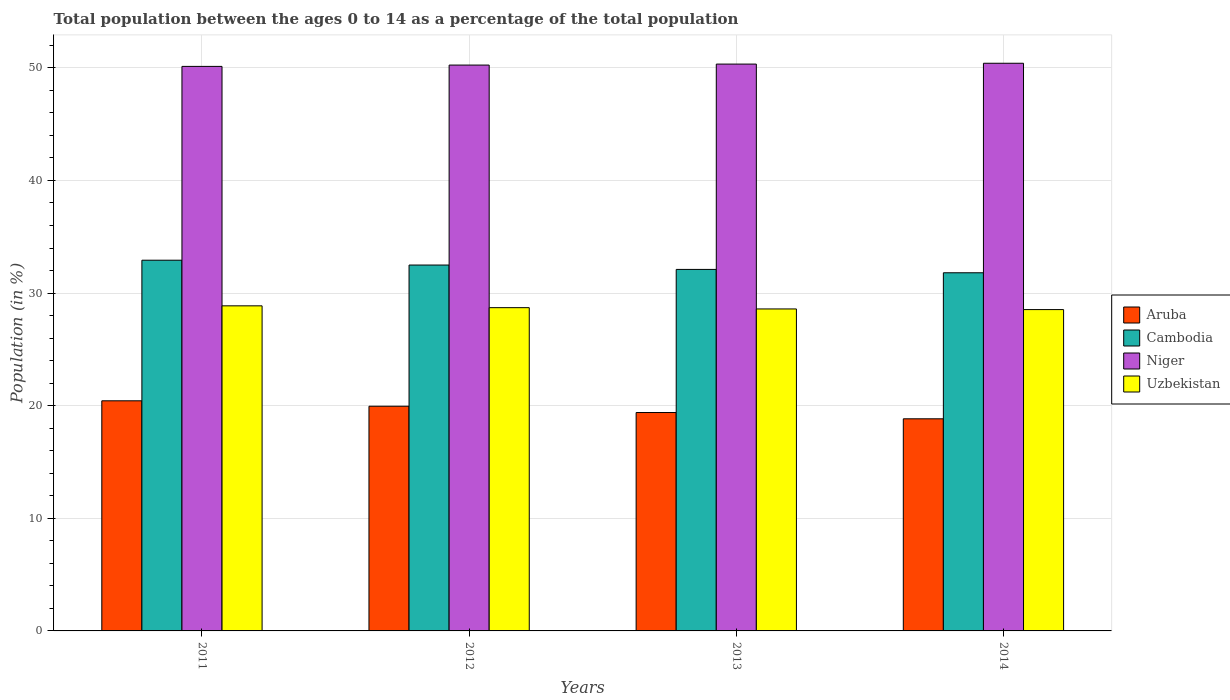How many different coloured bars are there?
Your response must be concise. 4. Are the number of bars per tick equal to the number of legend labels?
Give a very brief answer. Yes. Are the number of bars on each tick of the X-axis equal?
Offer a very short reply. Yes. How many bars are there on the 3rd tick from the left?
Ensure brevity in your answer.  4. How many bars are there on the 2nd tick from the right?
Your answer should be very brief. 4. What is the label of the 3rd group of bars from the left?
Your response must be concise. 2013. What is the percentage of the population ages 0 to 14 in Aruba in 2011?
Provide a short and direct response. 20.43. Across all years, what is the maximum percentage of the population ages 0 to 14 in Cambodia?
Your response must be concise. 32.92. Across all years, what is the minimum percentage of the population ages 0 to 14 in Cambodia?
Provide a short and direct response. 31.8. In which year was the percentage of the population ages 0 to 14 in Cambodia maximum?
Make the answer very short. 2011. What is the total percentage of the population ages 0 to 14 in Aruba in the graph?
Provide a short and direct response. 78.62. What is the difference between the percentage of the population ages 0 to 14 in Niger in 2013 and that in 2014?
Your answer should be compact. -0.07. What is the difference between the percentage of the population ages 0 to 14 in Aruba in 2012 and the percentage of the population ages 0 to 14 in Uzbekistan in 2013?
Offer a very short reply. -8.64. What is the average percentage of the population ages 0 to 14 in Cambodia per year?
Your response must be concise. 32.33. In the year 2013, what is the difference between the percentage of the population ages 0 to 14 in Niger and percentage of the population ages 0 to 14 in Uzbekistan?
Give a very brief answer. 21.74. In how many years, is the percentage of the population ages 0 to 14 in Cambodia greater than 26?
Keep it short and to the point. 4. What is the ratio of the percentage of the population ages 0 to 14 in Niger in 2011 to that in 2013?
Your answer should be very brief. 1. Is the percentage of the population ages 0 to 14 in Aruba in 2011 less than that in 2014?
Ensure brevity in your answer.  No. Is the difference between the percentage of the population ages 0 to 14 in Niger in 2012 and 2013 greater than the difference between the percentage of the population ages 0 to 14 in Uzbekistan in 2012 and 2013?
Provide a short and direct response. No. What is the difference between the highest and the second highest percentage of the population ages 0 to 14 in Aruba?
Offer a very short reply. 0.48. What is the difference between the highest and the lowest percentage of the population ages 0 to 14 in Niger?
Give a very brief answer. 0.28. In how many years, is the percentage of the population ages 0 to 14 in Niger greater than the average percentage of the population ages 0 to 14 in Niger taken over all years?
Offer a very short reply. 2. What does the 2nd bar from the left in 2014 represents?
Keep it short and to the point. Cambodia. What does the 1st bar from the right in 2012 represents?
Make the answer very short. Uzbekistan. How many bars are there?
Offer a terse response. 16. Are all the bars in the graph horizontal?
Your answer should be very brief. No. How many years are there in the graph?
Offer a terse response. 4. Where does the legend appear in the graph?
Keep it short and to the point. Center right. What is the title of the graph?
Offer a terse response. Total population between the ages 0 to 14 as a percentage of the total population. What is the label or title of the X-axis?
Offer a very short reply. Years. What is the Population (in %) in Aruba in 2011?
Provide a short and direct response. 20.43. What is the Population (in %) of Cambodia in 2011?
Your response must be concise. 32.92. What is the Population (in %) of Niger in 2011?
Your response must be concise. 50.13. What is the Population (in %) of Uzbekistan in 2011?
Provide a succinct answer. 28.87. What is the Population (in %) of Aruba in 2012?
Offer a terse response. 19.95. What is the Population (in %) in Cambodia in 2012?
Offer a very short reply. 32.49. What is the Population (in %) in Niger in 2012?
Make the answer very short. 50.25. What is the Population (in %) in Uzbekistan in 2012?
Your answer should be very brief. 28.71. What is the Population (in %) in Aruba in 2013?
Offer a very short reply. 19.39. What is the Population (in %) in Cambodia in 2013?
Your response must be concise. 32.1. What is the Population (in %) in Niger in 2013?
Offer a terse response. 50.34. What is the Population (in %) in Uzbekistan in 2013?
Offer a very short reply. 28.59. What is the Population (in %) in Aruba in 2014?
Offer a terse response. 18.84. What is the Population (in %) in Cambodia in 2014?
Give a very brief answer. 31.8. What is the Population (in %) of Niger in 2014?
Your answer should be compact. 50.41. What is the Population (in %) in Uzbekistan in 2014?
Provide a succinct answer. 28.53. Across all years, what is the maximum Population (in %) in Aruba?
Your answer should be compact. 20.43. Across all years, what is the maximum Population (in %) in Cambodia?
Provide a short and direct response. 32.92. Across all years, what is the maximum Population (in %) in Niger?
Offer a terse response. 50.41. Across all years, what is the maximum Population (in %) of Uzbekistan?
Keep it short and to the point. 28.87. Across all years, what is the minimum Population (in %) of Aruba?
Make the answer very short. 18.84. Across all years, what is the minimum Population (in %) in Cambodia?
Provide a short and direct response. 31.8. Across all years, what is the minimum Population (in %) in Niger?
Provide a succinct answer. 50.13. Across all years, what is the minimum Population (in %) in Uzbekistan?
Make the answer very short. 28.53. What is the total Population (in %) of Aruba in the graph?
Offer a very short reply. 78.62. What is the total Population (in %) in Cambodia in the graph?
Provide a succinct answer. 129.32. What is the total Population (in %) of Niger in the graph?
Give a very brief answer. 201.12. What is the total Population (in %) in Uzbekistan in the graph?
Offer a terse response. 114.7. What is the difference between the Population (in %) of Aruba in 2011 and that in 2012?
Your answer should be very brief. 0.48. What is the difference between the Population (in %) in Cambodia in 2011 and that in 2012?
Ensure brevity in your answer.  0.43. What is the difference between the Population (in %) in Niger in 2011 and that in 2012?
Your answer should be very brief. -0.12. What is the difference between the Population (in %) of Uzbekistan in 2011 and that in 2012?
Offer a terse response. 0.16. What is the difference between the Population (in %) of Aruba in 2011 and that in 2013?
Provide a succinct answer. 1.04. What is the difference between the Population (in %) of Cambodia in 2011 and that in 2013?
Provide a short and direct response. 0.82. What is the difference between the Population (in %) in Niger in 2011 and that in 2013?
Ensure brevity in your answer.  -0.21. What is the difference between the Population (in %) in Uzbekistan in 2011 and that in 2013?
Make the answer very short. 0.28. What is the difference between the Population (in %) in Aruba in 2011 and that in 2014?
Keep it short and to the point. 1.6. What is the difference between the Population (in %) of Cambodia in 2011 and that in 2014?
Make the answer very short. 1.12. What is the difference between the Population (in %) in Niger in 2011 and that in 2014?
Provide a succinct answer. -0.28. What is the difference between the Population (in %) in Uzbekistan in 2011 and that in 2014?
Offer a terse response. 0.33. What is the difference between the Population (in %) of Aruba in 2012 and that in 2013?
Offer a terse response. 0.56. What is the difference between the Population (in %) in Cambodia in 2012 and that in 2013?
Your response must be concise. 0.39. What is the difference between the Population (in %) of Niger in 2012 and that in 2013?
Offer a very short reply. -0.09. What is the difference between the Population (in %) of Uzbekistan in 2012 and that in 2013?
Offer a terse response. 0.11. What is the difference between the Population (in %) in Aruba in 2012 and that in 2014?
Your answer should be compact. 1.12. What is the difference between the Population (in %) in Cambodia in 2012 and that in 2014?
Your answer should be compact. 0.69. What is the difference between the Population (in %) of Niger in 2012 and that in 2014?
Offer a terse response. -0.16. What is the difference between the Population (in %) in Uzbekistan in 2012 and that in 2014?
Your answer should be very brief. 0.17. What is the difference between the Population (in %) in Aruba in 2013 and that in 2014?
Provide a succinct answer. 0.56. What is the difference between the Population (in %) of Cambodia in 2013 and that in 2014?
Provide a short and direct response. 0.3. What is the difference between the Population (in %) of Niger in 2013 and that in 2014?
Provide a succinct answer. -0.07. What is the difference between the Population (in %) of Uzbekistan in 2013 and that in 2014?
Offer a terse response. 0.06. What is the difference between the Population (in %) in Aruba in 2011 and the Population (in %) in Cambodia in 2012?
Your answer should be compact. -12.06. What is the difference between the Population (in %) in Aruba in 2011 and the Population (in %) in Niger in 2012?
Offer a very short reply. -29.81. What is the difference between the Population (in %) in Aruba in 2011 and the Population (in %) in Uzbekistan in 2012?
Provide a succinct answer. -8.27. What is the difference between the Population (in %) in Cambodia in 2011 and the Population (in %) in Niger in 2012?
Provide a short and direct response. -17.33. What is the difference between the Population (in %) of Cambodia in 2011 and the Population (in %) of Uzbekistan in 2012?
Your response must be concise. 4.21. What is the difference between the Population (in %) of Niger in 2011 and the Population (in %) of Uzbekistan in 2012?
Provide a succinct answer. 21.42. What is the difference between the Population (in %) in Aruba in 2011 and the Population (in %) in Cambodia in 2013?
Provide a succinct answer. -11.67. What is the difference between the Population (in %) of Aruba in 2011 and the Population (in %) of Niger in 2013?
Provide a succinct answer. -29.9. What is the difference between the Population (in %) of Aruba in 2011 and the Population (in %) of Uzbekistan in 2013?
Offer a terse response. -8.16. What is the difference between the Population (in %) of Cambodia in 2011 and the Population (in %) of Niger in 2013?
Keep it short and to the point. -17.42. What is the difference between the Population (in %) of Cambodia in 2011 and the Population (in %) of Uzbekistan in 2013?
Offer a very short reply. 4.33. What is the difference between the Population (in %) in Niger in 2011 and the Population (in %) in Uzbekistan in 2013?
Make the answer very short. 21.54. What is the difference between the Population (in %) of Aruba in 2011 and the Population (in %) of Cambodia in 2014?
Provide a short and direct response. -11.37. What is the difference between the Population (in %) of Aruba in 2011 and the Population (in %) of Niger in 2014?
Offer a very short reply. -29.97. What is the difference between the Population (in %) in Aruba in 2011 and the Population (in %) in Uzbekistan in 2014?
Offer a terse response. -8.1. What is the difference between the Population (in %) in Cambodia in 2011 and the Population (in %) in Niger in 2014?
Provide a succinct answer. -17.49. What is the difference between the Population (in %) of Cambodia in 2011 and the Population (in %) of Uzbekistan in 2014?
Offer a terse response. 4.38. What is the difference between the Population (in %) in Niger in 2011 and the Population (in %) in Uzbekistan in 2014?
Make the answer very short. 21.59. What is the difference between the Population (in %) in Aruba in 2012 and the Population (in %) in Cambodia in 2013?
Offer a terse response. -12.15. What is the difference between the Population (in %) of Aruba in 2012 and the Population (in %) of Niger in 2013?
Ensure brevity in your answer.  -30.38. What is the difference between the Population (in %) in Aruba in 2012 and the Population (in %) in Uzbekistan in 2013?
Make the answer very short. -8.64. What is the difference between the Population (in %) of Cambodia in 2012 and the Population (in %) of Niger in 2013?
Provide a succinct answer. -17.85. What is the difference between the Population (in %) in Cambodia in 2012 and the Population (in %) in Uzbekistan in 2013?
Offer a terse response. 3.9. What is the difference between the Population (in %) in Niger in 2012 and the Population (in %) in Uzbekistan in 2013?
Make the answer very short. 21.66. What is the difference between the Population (in %) in Aruba in 2012 and the Population (in %) in Cambodia in 2014?
Provide a succinct answer. -11.85. What is the difference between the Population (in %) of Aruba in 2012 and the Population (in %) of Niger in 2014?
Your answer should be compact. -30.46. What is the difference between the Population (in %) in Aruba in 2012 and the Population (in %) in Uzbekistan in 2014?
Offer a terse response. -8.58. What is the difference between the Population (in %) in Cambodia in 2012 and the Population (in %) in Niger in 2014?
Offer a very short reply. -17.92. What is the difference between the Population (in %) of Cambodia in 2012 and the Population (in %) of Uzbekistan in 2014?
Make the answer very short. 3.96. What is the difference between the Population (in %) of Niger in 2012 and the Population (in %) of Uzbekistan in 2014?
Offer a very short reply. 21.71. What is the difference between the Population (in %) in Aruba in 2013 and the Population (in %) in Cambodia in 2014?
Your answer should be very brief. -12.41. What is the difference between the Population (in %) in Aruba in 2013 and the Population (in %) in Niger in 2014?
Offer a terse response. -31.01. What is the difference between the Population (in %) in Aruba in 2013 and the Population (in %) in Uzbekistan in 2014?
Provide a short and direct response. -9.14. What is the difference between the Population (in %) of Cambodia in 2013 and the Population (in %) of Niger in 2014?
Provide a short and direct response. -18.31. What is the difference between the Population (in %) of Cambodia in 2013 and the Population (in %) of Uzbekistan in 2014?
Make the answer very short. 3.57. What is the difference between the Population (in %) in Niger in 2013 and the Population (in %) in Uzbekistan in 2014?
Offer a very short reply. 21.8. What is the average Population (in %) in Aruba per year?
Your response must be concise. 19.65. What is the average Population (in %) in Cambodia per year?
Keep it short and to the point. 32.33. What is the average Population (in %) of Niger per year?
Keep it short and to the point. 50.28. What is the average Population (in %) of Uzbekistan per year?
Your answer should be very brief. 28.67. In the year 2011, what is the difference between the Population (in %) of Aruba and Population (in %) of Cambodia?
Keep it short and to the point. -12.48. In the year 2011, what is the difference between the Population (in %) of Aruba and Population (in %) of Niger?
Keep it short and to the point. -29.7. In the year 2011, what is the difference between the Population (in %) in Aruba and Population (in %) in Uzbekistan?
Keep it short and to the point. -8.43. In the year 2011, what is the difference between the Population (in %) in Cambodia and Population (in %) in Niger?
Ensure brevity in your answer.  -17.21. In the year 2011, what is the difference between the Population (in %) in Cambodia and Population (in %) in Uzbekistan?
Give a very brief answer. 4.05. In the year 2011, what is the difference between the Population (in %) in Niger and Population (in %) in Uzbekistan?
Give a very brief answer. 21.26. In the year 2012, what is the difference between the Population (in %) of Aruba and Population (in %) of Cambodia?
Offer a very short reply. -12.54. In the year 2012, what is the difference between the Population (in %) of Aruba and Population (in %) of Niger?
Give a very brief answer. -30.29. In the year 2012, what is the difference between the Population (in %) of Aruba and Population (in %) of Uzbekistan?
Your response must be concise. -8.75. In the year 2012, what is the difference between the Population (in %) in Cambodia and Population (in %) in Niger?
Your response must be concise. -17.76. In the year 2012, what is the difference between the Population (in %) of Cambodia and Population (in %) of Uzbekistan?
Offer a terse response. 3.79. In the year 2012, what is the difference between the Population (in %) in Niger and Population (in %) in Uzbekistan?
Your response must be concise. 21.54. In the year 2013, what is the difference between the Population (in %) in Aruba and Population (in %) in Cambodia?
Your answer should be very brief. -12.71. In the year 2013, what is the difference between the Population (in %) in Aruba and Population (in %) in Niger?
Make the answer very short. -30.94. In the year 2013, what is the difference between the Population (in %) in Aruba and Population (in %) in Uzbekistan?
Your answer should be compact. -9.2. In the year 2013, what is the difference between the Population (in %) in Cambodia and Population (in %) in Niger?
Offer a very short reply. -18.23. In the year 2013, what is the difference between the Population (in %) in Cambodia and Population (in %) in Uzbekistan?
Provide a short and direct response. 3.51. In the year 2013, what is the difference between the Population (in %) of Niger and Population (in %) of Uzbekistan?
Give a very brief answer. 21.74. In the year 2014, what is the difference between the Population (in %) in Aruba and Population (in %) in Cambodia?
Your answer should be very brief. -12.97. In the year 2014, what is the difference between the Population (in %) of Aruba and Population (in %) of Niger?
Offer a very short reply. -31.57. In the year 2014, what is the difference between the Population (in %) of Aruba and Population (in %) of Uzbekistan?
Provide a succinct answer. -9.7. In the year 2014, what is the difference between the Population (in %) of Cambodia and Population (in %) of Niger?
Give a very brief answer. -18.6. In the year 2014, what is the difference between the Population (in %) of Cambodia and Population (in %) of Uzbekistan?
Ensure brevity in your answer.  3.27. In the year 2014, what is the difference between the Population (in %) of Niger and Population (in %) of Uzbekistan?
Provide a short and direct response. 21.87. What is the ratio of the Population (in %) of Aruba in 2011 to that in 2012?
Your answer should be compact. 1.02. What is the ratio of the Population (in %) in Cambodia in 2011 to that in 2012?
Keep it short and to the point. 1.01. What is the ratio of the Population (in %) in Uzbekistan in 2011 to that in 2012?
Give a very brief answer. 1.01. What is the ratio of the Population (in %) in Aruba in 2011 to that in 2013?
Your answer should be compact. 1.05. What is the ratio of the Population (in %) in Cambodia in 2011 to that in 2013?
Offer a terse response. 1.03. What is the ratio of the Population (in %) in Uzbekistan in 2011 to that in 2013?
Ensure brevity in your answer.  1.01. What is the ratio of the Population (in %) in Aruba in 2011 to that in 2014?
Keep it short and to the point. 1.08. What is the ratio of the Population (in %) in Cambodia in 2011 to that in 2014?
Offer a terse response. 1.04. What is the ratio of the Population (in %) of Uzbekistan in 2011 to that in 2014?
Make the answer very short. 1.01. What is the ratio of the Population (in %) in Aruba in 2012 to that in 2013?
Make the answer very short. 1.03. What is the ratio of the Population (in %) of Cambodia in 2012 to that in 2013?
Ensure brevity in your answer.  1.01. What is the ratio of the Population (in %) in Niger in 2012 to that in 2013?
Offer a very short reply. 1. What is the ratio of the Population (in %) in Aruba in 2012 to that in 2014?
Your answer should be compact. 1.06. What is the ratio of the Population (in %) of Cambodia in 2012 to that in 2014?
Make the answer very short. 1.02. What is the ratio of the Population (in %) in Aruba in 2013 to that in 2014?
Your answer should be very brief. 1.03. What is the ratio of the Population (in %) in Cambodia in 2013 to that in 2014?
Provide a short and direct response. 1.01. What is the ratio of the Population (in %) in Uzbekistan in 2013 to that in 2014?
Keep it short and to the point. 1. What is the difference between the highest and the second highest Population (in %) in Aruba?
Offer a terse response. 0.48. What is the difference between the highest and the second highest Population (in %) in Cambodia?
Give a very brief answer. 0.43. What is the difference between the highest and the second highest Population (in %) in Niger?
Your response must be concise. 0.07. What is the difference between the highest and the second highest Population (in %) of Uzbekistan?
Provide a succinct answer. 0.16. What is the difference between the highest and the lowest Population (in %) of Aruba?
Offer a very short reply. 1.6. What is the difference between the highest and the lowest Population (in %) of Cambodia?
Your answer should be compact. 1.12. What is the difference between the highest and the lowest Population (in %) in Niger?
Provide a short and direct response. 0.28. What is the difference between the highest and the lowest Population (in %) of Uzbekistan?
Give a very brief answer. 0.33. 